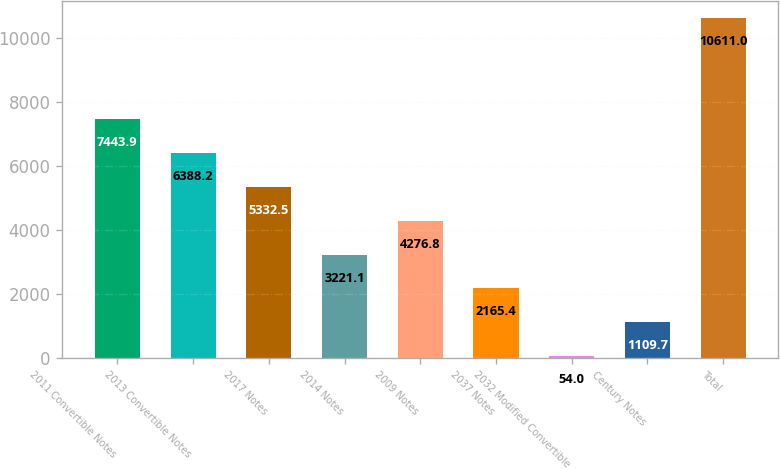Convert chart. <chart><loc_0><loc_0><loc_500><loc_500><bar_chart><fcel>2011 Convertible Notes<fcel>2013 Convertible Notes<fcel>2017 Notes<fcel>2014 Notes<fcel>2009 Notes<fcel>2037 Notes<fcel>2032 Modified Convertible<fcel>Century Notes<fcel>Total<nl><fcel>7443.9<fcel>6388.2<fcel>5332.5<fcel>3221.1<fcel>4276.8<fcel>2165.4<fcel>54<fcel>1109.7<fcel>10611<nl></chart> 